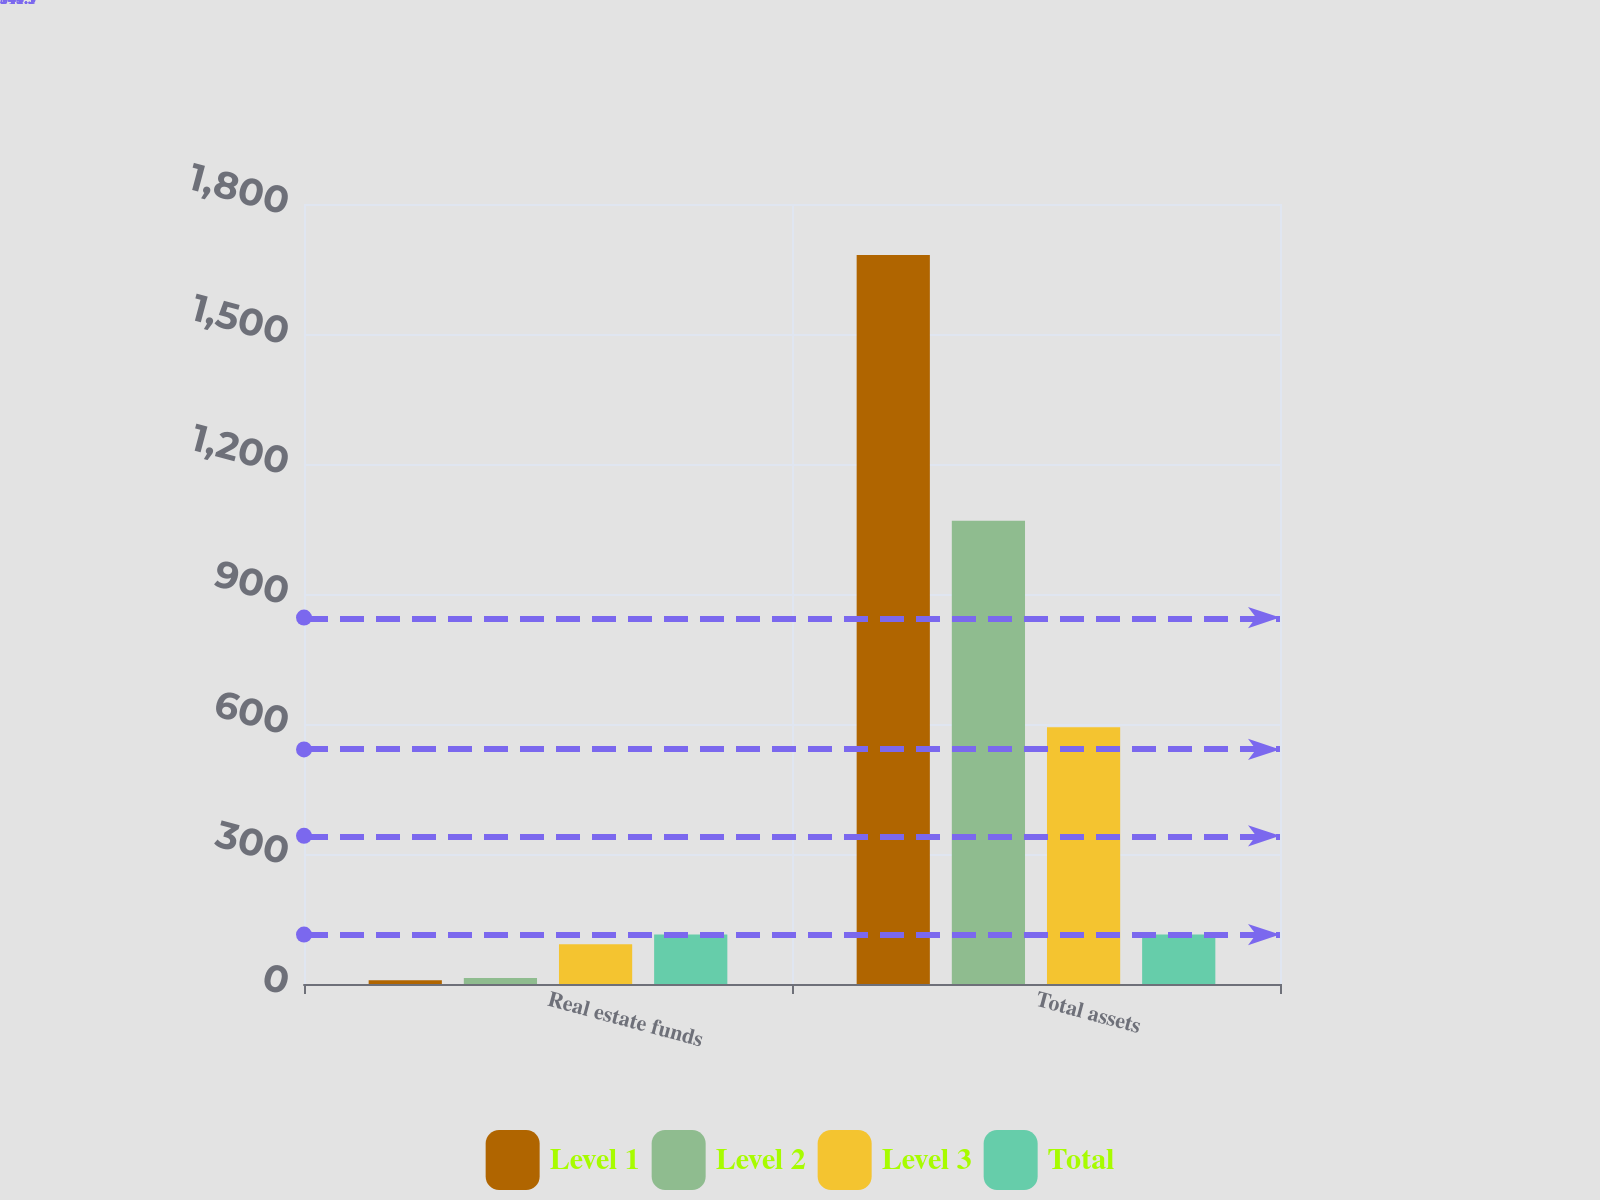Convert chart to OTSL. <chart><loc_0><loc_0><loc_500><loc_500><stacked_bar_chart><ecel><fcel>Real estate funds<fcel>Total assets<nl><fcel>Level 1<fcel>8.9<fcel>1682.1<nl><fcel>Level 2<fcel>13.7<fcel>1068.9<nl><fcel>Level 3<fcel>91.5<fcel>592.3<nl><fcel>Total<fcel>114.1<fcel>114.1<nl></chart> 